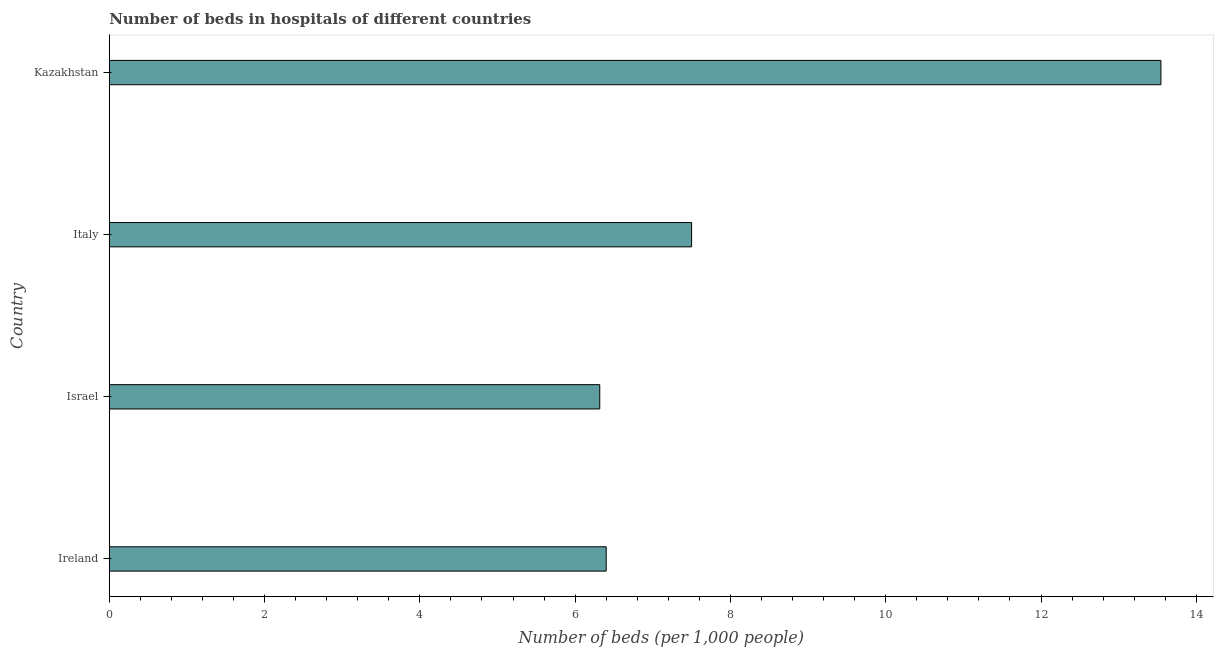What is the title of the graph?
Your answer should be very brief. Number of beds in hospitals of different countries. What is the label or title of the X-axis?
Offer a very short reply. Number of beds (per 1,0 people). What is the label or title of the Y-axis?
Provide a succinct answer. Country. What is the number of hospital beds in Israel?
Your response must be concise. 6.32. Across all countries, what is the maximum number of hospital beds?
Your answer should be compact. 13.54. Across all countries, what is the minimum number of hospital beds?
Give a very brief answer. 6.32. In which country was the number of hospital beds maximum?
Keep it short and to the point. Kazakhstan. What is the sum of the number of hospital beds?
Your answer should be very brief. 33.76. What is the difference between the number of hospital beds in Italy and Kazakhstan?
Provide a succinct answer. -6.04. What is the average number of hospital beds per country?
Your response must be concise. 8.44. What is the median number of hospital beds?
Ensure brevity in your answer.  6.95. What is the ratio of the number of hospital beds in Israel to that in Italy?
Offer a terse response. 0.84. Is the number of hospital beds in Ireland less than that in Kazakhstan?
Offer a very short reply. Yes. Is the difference between the number of hospital beds in Ireland and Israel greater than the difference between any two countries?
Your response must be concise. No. What is the difference between the highest and the second highest number of hospital beds?
Ensure brevity in your answer.  6.04. Is the sum of the number of hospital beds in Italy and Kazakhstan greater than the maximum number of hospital beds across all countries?
Ensure brevity in your answer.  Yes. What is the difference between the highest and the lowest number of hospital beds?
Provide a succinct answer. 7.23. How many bars are there?
Provide a succinct answer. 4. Are all the bars in the graph horizontal?
Your answer should be compact. Yes. What is the difference between two consecutive major ticks on the X-axis?
Provide a short and direct response. 2. What is the Number of beds (per 1,000 people) in Ireland?
Provide a succinct answer. 6.4. What is the Number of beds (per 1,000 people) of Israel?
Your response must be concise. 6.32. What is the Number of beds (per 1,000 people) in Kazakhstan?
Ensure brevity in your answer.  13.54. What is the difference between the Number of beds (per 1,000 people) in Ireland and Israel?
Make the answer very short. 0.08. What is the difference between the Number of beds (per 1,000 people) in Ireland and Kazakhstan?
Provide a succinct answer. -7.14. What is the difference between the Number of beds (per 1,000 people) in Israel and Italy?
Your answer should be very brief. -1.18. What is the difference between the Number of beds (per 1,000 people) in Israel and Kazakhstan?
Give a very brief answer. -7.23. What is the difference between the Number of beds (per 1,000 people) in Italy and Kazakhstan?
Keep it short and to the point. -6.04. What is the ratio of the Number of beds (per 1,000 people) in Ireland to that in Italy?
Give a very brief answer. 0.85. What is the ratio of the Number of beds (per 1,000 people) in Ireland to that in Kazakhstan?
Keep it short and to the point. 0.47. What is the ratio of the Number of beds (per 1,000 people) in Israel to that in Italy?
Ensure brevity in your answer.  0.84. What is the ratio of the Number of beds (per 1,000 people) in Israel to that in Kazakhstan?
Ensure brevity in your answer.  0.47. What is the ratio of the Number of beds (per 1,000 people) in Italy to that in Kazakhstan?
Offer a terse response. 0.55. 